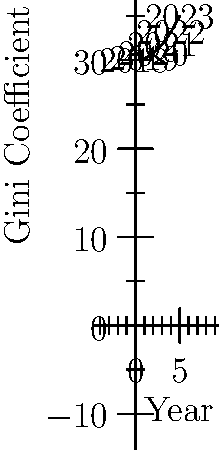As a student activist concerned with social justice, you're analyzing income inequality trends. The graph shows the Gini coefficient (a measure of income inequality) from 2018 to 2023. Calculate the average rate of change in income inequality between 2018 and 2023. To calculate the average rate of change, we need to follow these steps:

1. Identify the Gini coefficient values for 2018 and 2023:
   2018 (x = 0): y = f(0) = 0.2(0)^2 + 30 = 30
   2023 (x = 5): y = f(5) = 0.2(5)^2 + 30 = 35

2. Calculate the change in Gini coefficient:
   Δy = 35 - 30 = 5

3. Calculate the change in time (in years):
   Δx = 5 years

4. Apply the average rate of change formula:
   Average rate of change = Δy / Δx
   = 5 / 5 = 1

Therefore, the average rate of change in income inequality (as measured by the Gini coefficient) between 2018 and 2023 is 1 unit per year.
Answer: 1 unit per year 